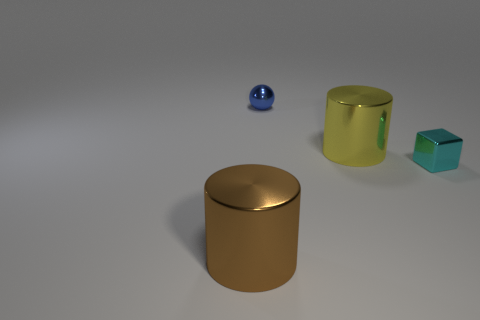Add 3 brown cylinders. How many objects exist? 7 Subtract all spheres. How many objects are left? 3 Add 4 large cylinders. How many large cylinders exist? 6 Subtract 0 purple blocks. How many objects are left? 4 Subtract all shiny blocks. Subtract all tiny cyan metal cubes. How many objects are left? 2 Add 1 small blue balls. How many small blue balls are left? 2 